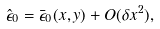Convert formula to latex. <formula><loc_0><loc_0><loc_500><loc_500>\hat { \epsilon } _ { 0 } = \bar { \epsilon } _ { 0 } ( x , y ) + O ( \delta x ^ { 2 } ) ,</formula> 